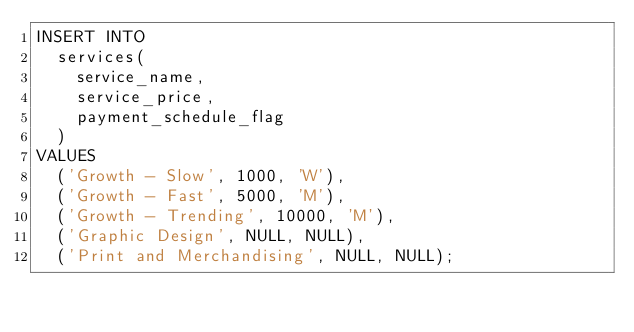Convert code to text. <code><loc_0><loc_0><loc_500><loc_500><_SQL_>INSERT INTO
	services(
		service_name,
		service_price,
		payment_schedule_flag
	)
VALUES
	('Growth - Slow', 1000, 'W'),
	('Growth - Fast', 5000, 'M'),
	('Growth - Trending', 10000, 'M'),
	('Graphic Design', NULL, NULL),
	('Print and Merchandising', NULL, NULL);</code> 